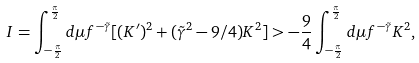<formula> <loc_0><loc_0><loc_500><loc_500>I = \int _ { - \frac { \pi } { 2 } } ^ { \frac { \pi } { 2 } } d \mu f ^ { - \tilde { \gamma } } [ ( K ^ { \prime } ) ^ { 2 } + ( \tilde { \gamma } ^ { 2 } - 9 / 4 ) K ^ { 2 } ] > - \frac { 9 } { 4 } \int _ { - \frac { \pi } { 2 } } ^ { \frac { \pi } { 2 } } d \mu f ^ { - \tilde { \gamma } } K ^ { 2 } ,</formula> 